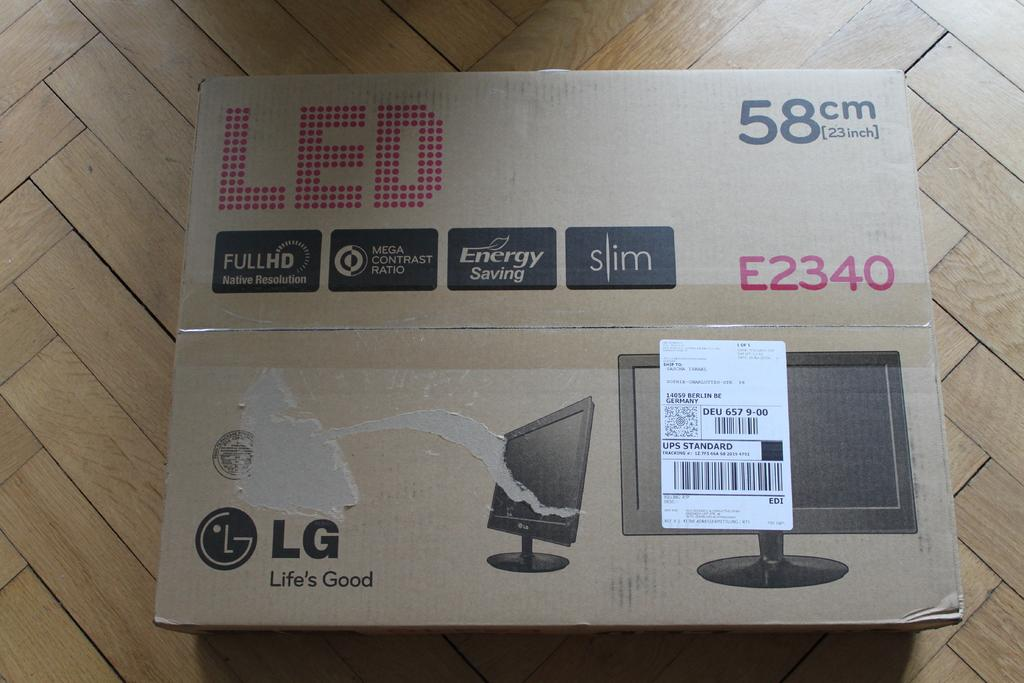Provide a one-sentence caption for the provided image. A box for an LED monitor by LG holds a 23 inch product. 